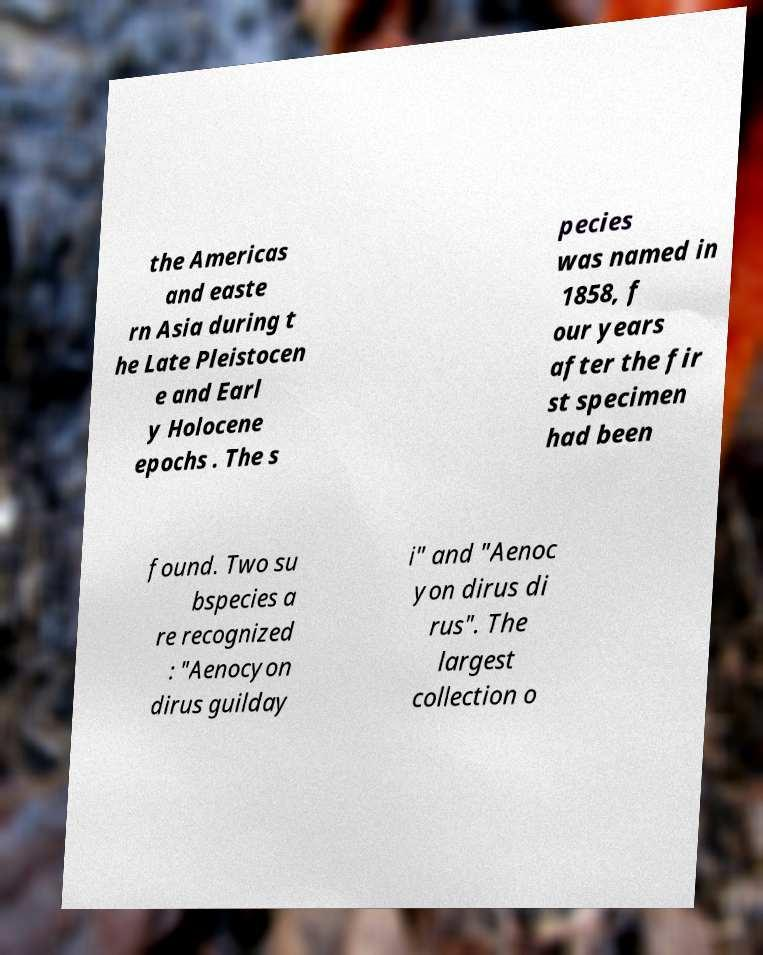There's text embedded in this image that I need extracted. Can you transcribe it verbatim? the Americas and easte rn Asia during t he Late Pleistocen e and Earl y Holocene epochs . The s pecies was named in 1858, f our years after the fir st specimen had been found. Two su bspecies a re recognized : "Aenocyon dirus guilday i" and "Aenoc yon dirus di rus". The largest collection o 